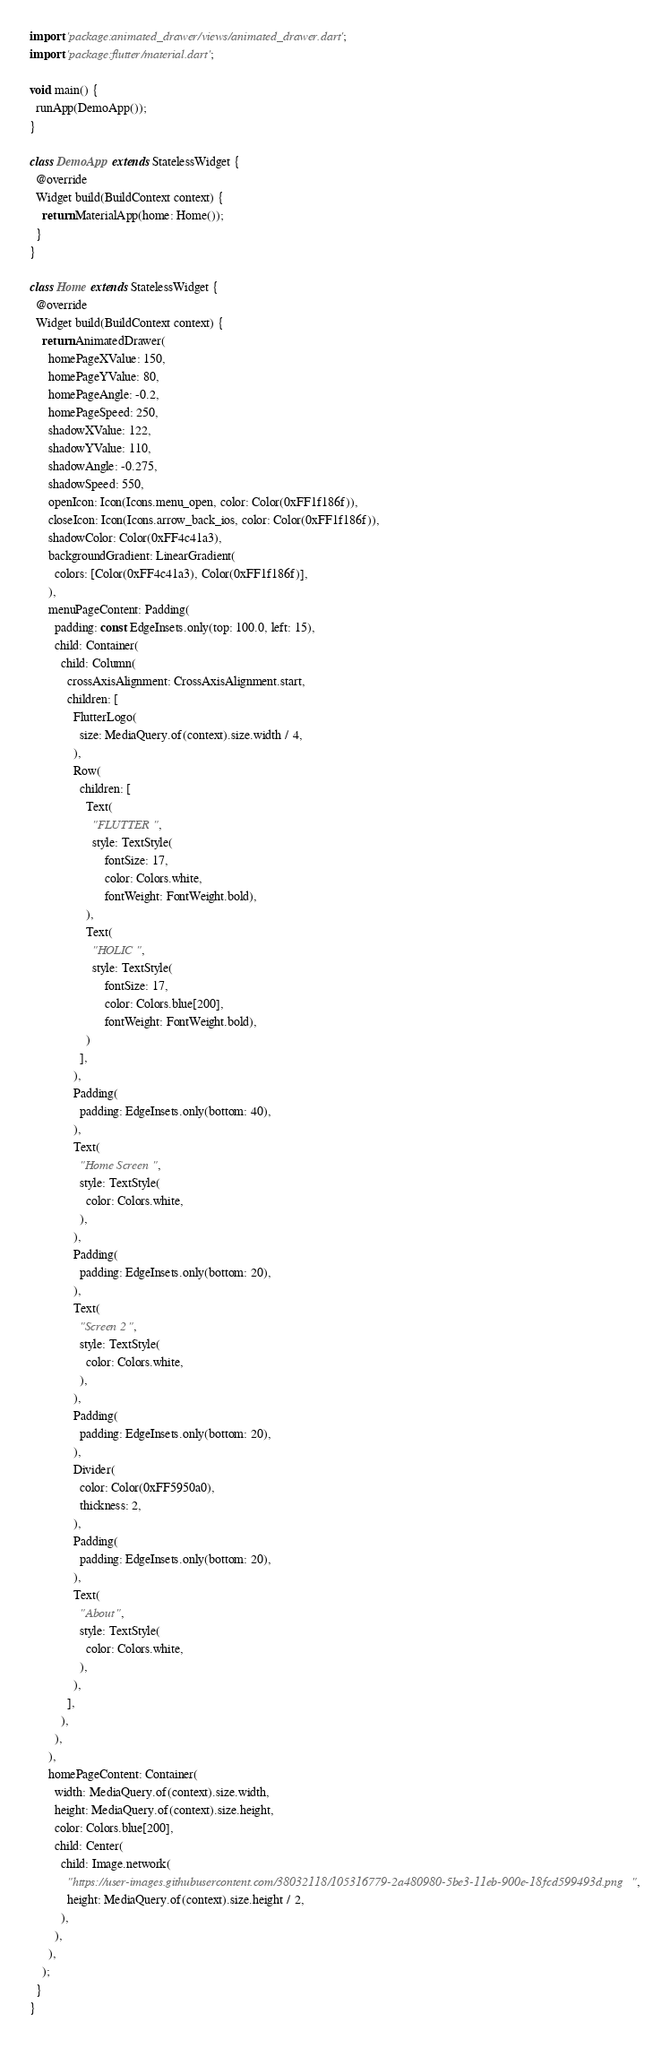Convert code to text. <code><loc_0><loc_0><loc_500><loc_500><_Dart_>import 'package:animated_drawer/views/animated_drawer.dart';
import 'package:flutter/material.dart';

void main() {
  runApp(DemoApp());
}

class DemoApp extends StatelessWidget {
  @override
  Widget build(BuildContext context) {
    return MaterialApp(home: Home());
  }
}

class Home extends StatelessWidget {
  @override
  Widget build(BuildContext context) {
    return AnimatedDrawer(
      homePageXValue: 150,
      homePageYValue: 80,
      homePageAngle: -0.2,
      homePageSpeed: 250,
      shadowXValue: 122,
      shadowYValue: 110,
      shadowAngle: -0.275,
      shadowSpeed: 550,
      openIcon: Icon(Icons.menu_open, color: Color(0xFF1f186f)),
      closeIcon: Icon(Icons.arrow_back_ios, color: Color(0xFF1f186f)),
      shadowColor: Color(0xFF4c41a3),
      backgroundGradient: LinearGradient(
        colors: [Color(0xFF4c41a3), Color(0xFF1f186f)],
      ),
      menuPageContent: Padding(
        padding: const EdgeInsets.only(top: 100.0, left: 15),
        child: Container(
          child: Column(
            crossAxisAlignment: CrossAxisAlignment.start,
            children: [
              FlutterLogo(
                size: MediaQuery.of(context).size.width / 4,
              ),
              Row(
                children: [
                  Text(
                    "FLUTTER",
                    style: TextStyle(
                        fontSize: 17,
                        color: Colors.white,
                        fontWeight: FontWeight.bold),
                  ),
                  Text(
                    "HOLIC",
                    style: TextStyle(
                        fontSize: 17,
                        color: Colors.blue[200],
                        fontWeight: FontWeight.bold),
                  )
                ],
              ),
              Padding(
                padding: EdgeInsets.only(bottom: 40),
              ),
              Text(
                "Home Screen",
                style: TextStyle(
                  color: Colors.white,
                ),
              ),
              Padding(
                padding: EdgeInsets.only(bottom: 20),
              ),
              Text(
                "Screen 2",
                style: TextStyle(
                  color: Colors.white,
                ),
              ),
              Padding(
                padding: EdgeInsets.only(bottom: 20),
              ),
              Divider(
                color: Color(0xFF5950a0),
                thickness: 2,
              ),
              Padding(
                padding: EdgeInsets.only(bottom: 20),
              ),
              Text(
                "About",
                style: TextStyle(
                  color: Colors.white,
                ),
              ),
            ],
          ),
        ),
      ),
      homePageContent: Container(
        width: MediaQuery.of(context).size.width,
        height: MediaQuery.of(context).size.height,
        color: Colors.blue[200],
        child: Center(
          child: Image.network(
            "https://user-images.githubusercontent.com/38032118/105316779-2a480980-5be3-11eb-900e-18fcd599493d.png",
            height: MediaQuery.of(context).size.height / 2,
          ),
        ),
      ),
    );
  }
}
</code> 